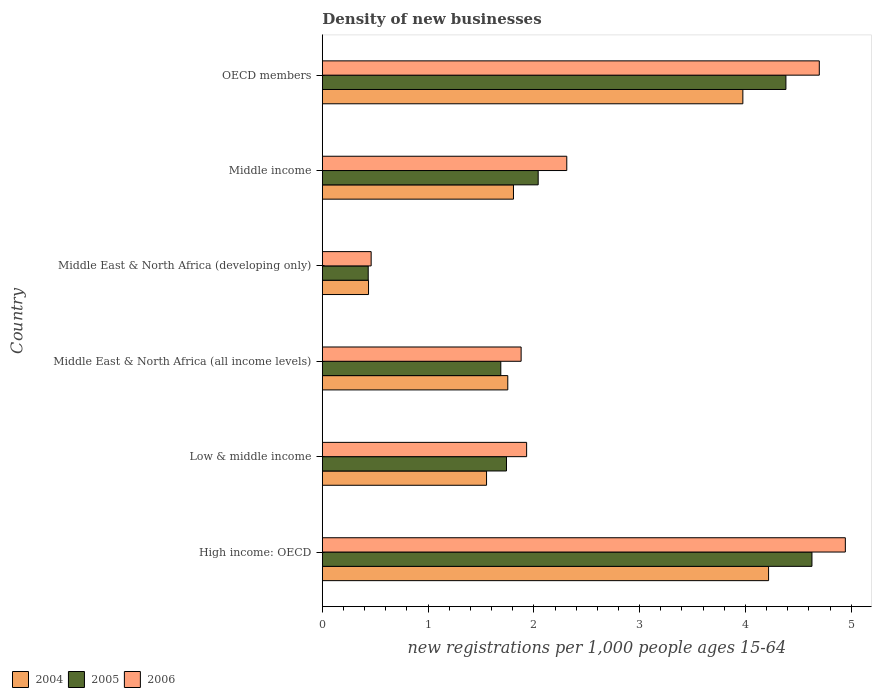How many different coloured bars are there?
Your answer should be very brief. 3. How many groups of bars are there?
Offer a terse response. 6. Are the number of bars per tick equal to the number of legend labels?
Your answer should be compact. Yes. Are the number of bars on each tick of the Y-axis equal?
Give a very brief answer. Yes. What is the number of new registrations in 2004 in Middle income?
Provide a succinct answer. 1.81. Across all countries, what is the maximum number of new registrations in 2004?
Provide a short and direct response. 4.22. Across all countries, what is the minimum number of new registrations in 2005?
Your answer should be compact. 0.43. In which country was the number of new registrations in 2006 maximum?
Your response must be concise. High income: OECD. In which country was the number of new registrations in 2006 minimum?
Ensure brevity in your answer.  Middle East & North Africa (developing only). What is the total number of new registrations in 2006 in the graph?
Offer a terse response. 16.23. What is the difference between the number of new registrations in 2006 in Middle East & North Africa (all income levels) and that in OECD members?
Your answer should be very brief. -2.82. What is the difference between the number of new registrations in 2005 in Middle East & North Africa (developing only) and the number of new registrations in 2004 in Middle East & North Africa (all income levels)?
Make the answer very short. -1.32. What is the average number of new registrations in 2004 per country?
Make the answer very short. 2.29. What is the difference between the number of new registrations in 2005 and number of new registrations in 2006 in OECD members?
Provide a short and direct response. -0.32. In how many countries, is the number of new registrations in 2006 greater than 4.2 ?
Your answer should be compact. 2. What is the ratio of the number of new registrations in 2005 in Middle East & North Africa (developing only) to that in Middle income?
Make the answer very short. 0.21. Is the number of new registrations in 2006 in Middle income less than that in OECD members?
Offer a very short reply. Yes. What is the difference between the highest and the second highest number of new registrations in 2006?
Your response must be concise. 0.25. What is the difference between the highest and the lowest number of new registrations in 2006?
Offer a terse response. 4.48. In how many countries, is the number of new registrations in 2005 greater than the average number of new registrations in 2005 taken over all countries?
Give a very brief answer. 2. What does the 2nd bar from the top in High income: OECD represents?
Provide a succinct answer. 2005. Are all the bars in the graph horizontal?
Provide a short and direct response. Yes. How many countries are there in the graph?
Your answer should be compact. 6. Are the values on the major ticks of X-axis written in scientific E-notation?
Make the answer very short. No. Where does the legend appear in the graph?
Make the answer very short. Bottom left. What is the title of the graph?
Keep it short and to the point. Density of new businesses. Does "1979" appear as one of the legend labels in the graph?
Provide a succinct answer. No. What is the label or title of the X-axis?
Make the answer very short. New registrations per 1,0 people ages 15-64. What is the label or title of the Y-axis?
Make the answer very short. Country. What is the new registrations per 1,000 people ages 15-64 in 2004 in High income: OECD?
Your answer should be very brief. 4.22. What is the new registrations per 1,000 people ages 15-64 in 2005 in High income: OECD?
Your answer should be very brief. 4.63. What is the new registrations per 1,000 people ages 15-64 in 2006 in High income: OECD?
Your answer should be very brief. 4.94. What is the new registrations per 1,000 people ages 15-64 of 2004 in Low & middle income?
Provide a succinct answer. 1.55. What is the new registrations per 1,000 people ages 15-64 of 2005 in Low & middle income?
Offer a very short reply. 1.74. What is the new registrations per 1,000 people ages 15-64 in 2006 in Low & middle income?
Your response must be concise. 1.93. What is the new registrations per 1,000 people ages 15-64 of 2004 in Middle East & North Africa (all income levels)?
Provide a short and direct response. 1.75. What is the new registrations per 1,000 people ages 15-64 in 2005 in Middle East & North Africa (all income levels)?
Provide a short and direct response. 1.69. What is the new registrations per 1,000 people ages 15-64 of 2006 in Middle East & North Africa (all income levels)?
Your answer should be compact. 1.88. What is the new registrations per 1,000 people ages 15-64 of 2004 in Middle East & North Africa (developing only)?
Keep it short and to the point. 0.44. What is the new registrations per 1,000 people ages 15-64 of 2005 in Middle East & North Africa (developing only)?
Offer a very short reply. 0.43. What is the new registrations per 1,000 people ages 15-64 in 2006 in Middle East & North Africa (developing only)?
Provide a short and direct response. 0.46. What is the new registrations per 1,000 people ages 15-64 in 2004 in Middle income?
Provide a succinct answer. 1.81. What is the new registrations per 1,000 people ages 15-64 of 2005 in Middle income?
Provide a short and direct response. 2.04. What is the new registrations per 1,000 people ages 15-64 in 2006 in Middle income?
Provide a succinct answer. 2.31. What is the new registrations per 1,000 people ages 15-64 in 2004 in OECD members?
Your answer should be compact. 3.98. What is the new registrations per 1,000 people ages 15-64 in 2005 in OECD members?
Your answer should be compact. 4.38. What is the new registrations per 1,000 people ages 15-64 of 2006 in OECD members?
Provide a short and direct response. 4.7. Across all countries, what is the maximum new registrations per 1,000 people ages 15-64 in 2004?
Offer a very short reply. 4.22. Across all countries, what is the maximum new registrations per 1,000 people ages 15-64 in 2005?
Offer a terse response. 4.63. Across all countries, what is the maximum new registrations per 1,000 people ages 15-64 of 2006?
Offer a terse response. 4.94. Across all countries, what is the minimum new registrations per 1,000 people ages 15-64 in 2004?
Make the answer very short. 0.44. Across all countries, what is the minimum new registrations per 1,000 people ages 15-64 of 2005?
Provide a short and direct response. 0.43. Across all countries, what is the minimum new registrations per 1,000 people ages 15-64 of 2006?
Keep it short and to the point. 0.46. What is the total new registrations per 1,000 people ages 15-64 in 2004 in the graph?
Offer a terse response. 13.74. What is the total new registrations per 1,000 people ages 15-64 in 2005 in the graph?
Your answer should be very brief. 14.92. What is the total new registrations per 1,000 people ages 15-64 of 2006 in the graph?
Give a very brief answer. 16.23. What is the difference between the new registrations per 1,000 people ages 15-64 of 2004 in High income: OECD and that in Low & middle income?
Ensure brevity in your answer.  2.67. What is the difference between the new registrations per 1,000 people ages 15-64 of 2005 in High income: OECD and that in Low & middle income?
Ensure brevity in your answer.  2.89. What is the difference between the new registrations per 1,000 people ages 15-64 in 2006 in High income: OECD and that in Low & middle income?
Provide a short and direct response. 3.01. What is the difference between the new registrations per 1,000 people ages 15-64 in 2004 in High income: OECD and that in Middle East & North Africa (all income levels)?
Ensure brevity in your answer.  2.47. What is the difference between the new registrations per 1,000 people ages 15-64 in 2005 in High income: OECD and that in Middle East & North Africa (all income levels)?
Offer a terse response. 2.94. What is the difference between the new registrations per 1,000 people ages 15-64 of 2006 in High income: OECD and that in Middle East & North Africa (all income levels)?
Offer a terse response. 3.07. What is the difference between the new registrations per 1,000 people ages 15-64 of 2004 in High income: OECD and that in Middle East & North Africa (developing only)?
Provide a short and direct response. 3.78. What is the difference between the new registrations per 1,000 people ages 15-64 of 2005 in High income: OECD and that in Middle East & North Africa (developing only)?
Ensure brevity in your answer.  4.2. What is the difference between the new registrations per 1,000 people ages 15-64 of 2006 in High income: OECD and that in Middle East & North Africa (developing only)?
Offer a very short reply. 4.48. What is the difference between the new registrations per 1,000 people ages 15-64 of 2004 in High income: OECD and that in Middle income?
Provide a short and direct response. 2.41. What is the difference between the new registrations per 1,000 people ages 15-64 of 2005 in High income: OECD and that in Middle income?
Offer a terse response. 2.59. What is the difference between the new registrations per 1,000 people ages 15-64 in 2006 in High income: OECD and that in Middle income?
Give a very brief answer. 2.63. What is the difference between the new registrations per 1,000 people ages 15-64 of 2004 in High income: OECD and that in OECD members?
Make the answer very short. 0.24. What is the difference between the new registrations per 1,000 people ages 15-64 of 2005 in High income: OECD and that in OECD members?
Make the answer very short. 0.25. What is the difference between the new registrations per 1,000 people ages 15-64 of 2006 in High income: OECD and that in OECD members?
Offer a very short reply. 0.25. What is the difference between the new registrations per 1,000 people ages 15-64 of 2004 in Low & middle income and that in Middle East & North Africa (all income levels)?
Ensure brevity in your answer.  -0.2. What is the difference between the new registrations per 1,000 people ages 15-64 of 2005 in Low & middle income and that in Middle East & North Africa (all income levels)?
Offer a very short reply. 0.05. What is the difference between the new registrations per 1,000 people ages 15-64 in 2006 in Low & middle income and that in Middle East & North Africa (all income levels)?
Your response must be concise. 0.05. What is the difference between the new registrations per 1,000 people ages 15-64 in 2004 in Low & middle income and that in Middle East & North Africa (developing only)?
Provide a succinct answer. 1.12. What is the difference between the new registrations per 1,000 people ages 15-64 in 2005 in Low & middle income and that in Middle East & North Africa (developing only)?
Make the answer very short. 1.31. What is the difference between the new registrations per 1,000 people ages 15-64 of 2006 in Low & middle income and that in Middle East & North Africa (developing only)?
Give a very brief answer. 1.47. What is the difference between the new registrations per 1,000 people ages 15-64 in 2004 in Low & middle income and that in Middle income?
Ensure brevity in your answer.  -0.25. What is the difference between the new registrations per 1,000 people ages 15-64 in 2005 in Low & middle income and that in Middle income?
Offer a terse response. -0.3. What is the difference between the new registrations per 1,000 people ages 15-64 in 2006 in Low & middle income and that in Middle income?
Provide a succinct answer. -0.38. What is the difference between the new registrations per 1,000 people ages 15-64 of 2004 in Low & middle income and that in OECD members?
Offer a terse response. -2.42. What is the difference between the new registrations per 1,000 people ages 15-64 of 2005 in Low & middle income and that in OECD members?
Your answer should be very brief. -2.64. What is the difference between the new registrations per 1,000 people ages 15-64 of 2006 in Low & middle income and that in OECD members?
Give a very brief answer. -2.77. What is the difference between the new registrations per 1,000 people ages 15-64 in 2004 in Middle East & North Africa (all income levels) and that in Middle East & North Africa (developing only)?
Offer a very short reply. 1.32. What is the difference between the new registrations per 1,000 people ages 15-64 of 2005 in Middle East & North Africa (all income levels) and that in Middle East & North Africa (developing only)?
Offer a terse response. 1.25. What is the difference between the new registrations per 1,000 people ages 15-64 in 2006 in Middle East & North Africa (all income levels) and that in Middle East & North Africa (developing only)?
Provide a short and direct response. 1.42. What is the difference between the new registrations per 1,000 people ages 15-64 of 2004 in Middle East & North Africa (all income levels) and that in Middle income?
Keep it short and to the point. -0.05. What is the difference between the new registrations per 1,000 people ages 15-64 of 2005 in Middle East & North Africa (all income levels) and that in Middle income?
Offer a very short reply. -0.35. What is the difference between the new registrations per 1,000 people ages 15-64 in 2006 in Middle East & North Africa (all income levels) and that in Middle income?
Offer a terse response. -0.43. What is the difference between the new registrations per 1,000 people ages 15-64 of 2004 in Middle East & North Africa (all income levels) and that in OECD members?
Your answer should be very brief. -2.22. What is the difference between the new registrations per 1,000 people ages 15-64 in 2005 in Middle East & North Africa (all income levels) and that in OECD members?
Your response must be concise. -2.7. What is the difference between the new registrations per 1,000 people ages 15-64 of 2006 in Middle East & North Africa (all income levels) and that in OECD members?
Offer a very short reply. -2.82. What is the difference between the new registrations per 1,000 people ages 15-64 of 2004 in Middle East & North Africa (developing only) and that in Middle income?
Give a very brief answer. -1.37. What is the difference between the new registrations per 1,000 people ages 15-64 of 2005 in Middle East & North Africa (developing only) and that in Middle income?
Give a very brief answer. -1.61. What is the difference between the new registrations per 1,000 people ages 15-64 in 2006 in Middle East & North Africa (developing only) and that in Middle income?
Give a very brief answer. -1.85. What is the difference between the new registrations per 1,000 people ages 15-64 in 2004 in Middle East & North Africa (developing only) and that in OECD members?
Your answer should be compact. -3.54. What is the difference between the new registrations per 1,000 people ages 15-64 of 2005 in Middle East & North Africa (developing only) and that in OECD members?
Make the answer very short. -3.95. What is the difference between the new registrations per 1,000 people ages 15-64 in 2006 in Middle East & North Africa (developing only) and that in OECD members?
Offer a terse response. -4.24. What is the difference between the new registrations per 1,000 people ages 15-64 in 2004 in Middle income and that in OECD members?
Ensure brevity in your answer.  -2.17. What is the difference between the new registrations per 1,000 people ages 15-64 in 2005 in Middle income and that in OECD members?
Ensure brevity in your answer.  -2.34. What is the difference between the new registrations per 1,000 people ages 15-64 in 2006 in Middle income and that in OECD members?
Keep it short and to the point. -2.39. What is the difference between the new registrations per 1,000 people ages 15-64 in 2004 in High income: OECD and the new registrations per 1,000 people ages 15-64 in 2005 in Low & middle income?
Offer a terse response. 2.48. What is the difference between the new registrations per 1,000 people ages 15-64 in 2004 in High income: OECD and the new registrations per 1,000 people ages 15-64 in 2006 in Low & middle income?
Your response must be concise. 2.29. What is the difference between the new registrations per 1,000 people ages 15-64 of 2005 in High income: OECD and the new registrations per 1,000 people ages 15-64 of 2006 in Low & middle income?
Your answer should be very brief. 2.7. What is the difference between the new registrations per 1,000 people ages 15-64 of 2004 in High income: OECD and the new registrations per 1,000 people ages 15-64 of 2005 in Middle East & North Africa (all income levels)?
Your response must be concise. 2.53. What is the difference between the new registrations per 1,000 people ages 15-64 of 2004 in High income: OECD and the new registrations per 1,000 people ages 15-64 of 2006 in Middle East & North Africa (all income levels)?
Your answer should be compact. 2.34. What is the difference between the new registrations per 1,000 people ages 15-64 of 2005 in High income: OECD and the new registrations per 1,000 people ages 15-64 of 2006 in Middle East & North Africa (all income levels)?
Give a very brief answer. 2.75. What is the difference between the new registrations per 1,000 people ages 15-64 of 2004 in High income: OECD and the new registrations per 1,000 people ages 15-64 of 2005 in Middle East & North Africa (developing only)?
Make the answer very short. 3.79. What is the difference between the new registrations per 1,000 people ages 15-64 in 2004 in High income: OECD and the new registrations per 1,000 people ages 15-64 in 2006 in Middle East & North Africa (developing only)?
Give a very brief answer. 3.76. What is the difference between the new registrations per 1,000 people ages 15-64 in 2005 in High income: OECD and the new registrations per 1,000 people ages 15-64 in 2006 in Middle East & North Africa (developing only)?
Your answer should be very brief. 4.17. What is the difference between the new registrations per 1,000 people ages 15-64 of 2004 in High income: OECD and the new registrations per 1,000 people ages 15-64 of 2005 in Middle income?
Your response must be concise. 2.18. What is the difference between the new registrations per 1,000 people ages 15-64 in 2004 in High income: OECD and the new registrations per 1,000 people ages 15-64 in 2006 in Middle income?
Give a very brief answer. 1.91. What is the difference between the new registrations per 1,000 people ages 15-64 of 2005 in High income: OECD and the new registrations per 1,000 people ages 15-64 of 2006 in Middle income?
Make the answer very short. 2.32. What is the difference between the new registrations per 1,000 people ages 15-64 in 2004 in High income: OECD and the new registrations per 1,000 people ages 15-64 in 2005 in OECD members?
Provide a short and direct response. -0.16. What is the difference between the new registrations per 1,000 people ages 15-64 in 2004 in High income: OECD and the new registrations per 1,000 people ages 15-64 in 2006 in OECD members?
Your answer should be very brief. -0.48. What is the difference between the new registrations per 1,000 people ages 15-64 of 2005 in High income: OECD and the new registrations per 1,000 people ages 15-64 of 2006 in OECD members?
Ensure brevity in your answer.  -0.07. What is the difference between the new registrations per 1,000 people ages 15-64 in 2004 in Low & middle income and the new registrations per 1,000 people ages 15-64 in 2005 in Middle East & North Africa (all income levels)?
Give a very brief answer. -0.13. What is the difference between the new registrations per 1,000 people ages 15-64 in 2004 in Low & middle income and the new registrations per 1,000 people ages 15-64 in 2006 in Middle East & North Africa (all income levels)?
Your response must be concise. -0.33. What is the difference between the new registrations per 1,000 people ages 15-64 in 2005 in Low & middle income and the new registrations per 1,000 people ages 15-64 in 2006 in Middle East & North Africa (all income levels)?
Offer a very short reply. -0.14. What is the difference between the new registrations per 1,000 people ages 15-64 in 2004 in Low & middle income and the new registrations per 1,000 people ages 15-64 in 2005 in Middle East & North Africa (developing only)?
Your response must be concise. 1.12. What is the difference between the new registrations per 1,000 people ages 15-64 in 2004 in Low & middle income and the new registrations per 1,000 people ages 15-64 in 2006 in Middle East & North Africa (developing only)?
Offer a terse response. 1.09. What is the difference between the new registrations per 1,000 people ages 15-64 of 2005 in Low & middle income and the new registrations per 1,000 people ages 15-64 of 2006 in Middle East & North Africa (developing only)?
Give a very brief answer. 1.28. What is the difference between the new registrations per 1,000 people ages 15-64 in 2004 in Low & middle income and the new registrations per 1,000 people ages 15-64 in 2005 in Middle income?
Provide a succinct answer. -0.49. What is the difference between the new registrations per 1,000 people ages 15-64 in 2004 in Low & middle income and the new registrations per 1,000 people ages 15-64 in 2006 in Middle income?
Your response must be concise. -0.76. What is the difference between the new registrations per 1,000 people ages 15-64 in 2005 in Low & middle income and the new registrations per 1,000 people ages 15-64 in 2006 in Middle income?
Make the answer very short. -0.57. What is the difference between the new registrations per 1,000 people ages 15-64 of 2004 in Low & middle income and the new registrations per 1,000 people ages 15-64 of 2005 in OECD members?
Your answer should be compact. -2.83. What is the difference between the new registrations per 1,000 people ages 15-64 in 2004 in Low & middle income and the new registrations per 1,000 people ages 15-64 in 2006 in OECD members?
Your response must be concise. -3.15. What is the difference between the new registrations per 1,000 people ages 15-64 of 2005 in Low & middle income and the new registrations per 1,000 people ages 15-64 of 2006 in OECD members?
Your answer should be compact. -2.96. What is the difference between the new registrations per 1,000 people ages 15-64 of 2004 in Middle East & North Africa (all income levels) and the new registrations per 1,000 people ages 15-64 of 2005 in Middle East & North Africa (developing only)?
Offer a terse response. 1.32. What is the difference between the new registrations per 1,000 people ages 15-64 of 2004 in Middle East & North Africa (all income levels) and the new registrations per 1,000 people ages 15-64 of 2006 in Middle East & North Africa (developing only)?
Provide a succinct answer. 1.29. What is the difference between the new registrations per 1,000 people ages 15-64 in 2005 in Middle East & North Africa (all income levels) and the new registrations per 1,000 people ages 15-64 in 2006 in Middle East & North Africa (developing only)?
Offer a very short reply. 1.23. What is the difference between the new registrations per 1,000 people ages 15-64 of 2004 in Middle East & North Africa (all income levels) and the new registrations per 1,000 people ages 15-64 of 2005 in Middle income?
Your answer should be compact. -0.29. What is the difference between the new registrations per 1,000 people ages 15-64 in 2004 in Middle East & North Africa (all income levels) and the new registrations per 1,000 people ages 15-64 in 2006 in Middle income?
Your answer should be compact. -0.56. What is the difference between the new registrations per 1,000 people ages 15-64 of 2005 in Middle East & North Africa (all income levels) and the new registrations per 1,000 people ages 15-64 of 2006 in Middle income?
Provide a succinct answer. -0.62. What is the difference between the new registrations per 1,000 people ages 15-64 of 2004 in Middle East & North Africa (all income levels) and the new registrations per 1,000 people ages 15-64 of 2005 in OECD members?
Keep it short and to the point. -2.63. What is the difference between the new registrations per 1,000 people ages 15-64 in 2004 in Middle East & North Africa (all income levels) and the new registrations per 1,000 people ages 15-64 in 2006 in OECD members?
Provide a short and direct response. -2.95. What is the difference between the new registrations per 1,000 people ages 15-64 of 2005 in Middle East & North Africa (all income levels) and the new registrations per 1,000 people ages 15-64 of 2006 in OECD members?
Your answer should be very brief. -3.01. What is the difference between the new registrations per 1,000 people ages 15-64 of 2004 in Middle East & North Africa (developing only) and the new registrations per 1,000 people ages 15-64 of 2005 in Middle income?
Make the answer very short. -1.6. What is the difference between the new registrations per 1,000 people ages 15-64 of 2004 in Middle East & North Africa (developing only) and the new registrations per 1,000 people ages 15-64 of 2006 in Middle income?
Your answer should be very brief. -1.87. What is the difference between the new registrations per 1,000 people ages 15-64 of 2005 in Middle East & North Africa (developing only) and the new registrations per 1,000 people ages 15-64 of 2006 in Middle income?
Your answer should be compact. -1.88. What is the difference between the new registrations per 1,000 people ages 15-64 of 2004 in Middle East & North Africa (developing only) and the new registrations per 1,000 people ages 15-64 of 2005 in OECD members?
Make the answer very short. -3.95. What is the difference between the new registrations per 1,000 people ages 15-64 in 2004 in Middle East & North Africa (developing only) and the new registrations per 1,000 people ages 15-64 in 2006 in OECD members?
Make the answer very short. -4.26. What is the difference between the new registrations per 1,000 people ages 15-64 of 2005 in Middle East & North Africa (developing only) and the new registrations per 1,000 people ages 15-64 of 2006 in OECD members?
Your answer should be compact. -4.26. What is the difference between the new registrations per 1,000 people ages 15-64 in 2004 in Middle income and the new registrations per 1,000 people ages 15-64 in 2005 in OECD members?
Make the answer very short. -2.58. What is the difference between the new registrations per 1,000 people ages 15-64 in 2004 in Middle income and the new registrations per 1,000 people ages 15-64 in 2006 in OECD members?
Provide a short and direct response. -2.89. What is the difference between the new registrations per 1,000 people ages 15-64 of 2005 in Middle income and the new registrations per 1,000 people ages 15-64 of 2006 in OECD members?
Offer a very short reply. -2.66. What is the average new registrations per 1,000 people ages 15-64 in 2004 per country?
Provide a short and direct response. 2.29. What is the average new registrations per 1,000 people ages 15-64 in 2005 per country?
Your response must be concise. 2.49. What is the average new registrations per 1,000 people ages 15-64 in 2006 per country?
Your answer should be compact. 2.7. What is the difference between the new registrations per 1,000 people ages 15-64 in 2004 and new registrations per 1,000 people ages 15-64 in 2005 in High income: OECD?
Provide a short and direct response. -0.41. What is the difference between the new registrations per 1,000 people ages 15-64 of 2004 and new registrations per 1,000 people ages 15-64 of 2006 in High income: OECD?
Offer a very short reply. -0.73. What is the difference between the new registrations per 1,000 people ages 15-64 of 2005 and new registrations per 1,000 people ages 15-64 of 2006 in High income: OECD?
Your answer should be compact. -0.32. What is the difference between the new registrations per 1,000 people ages 15-64 of 2004 and new registrations per 1,000 people ages 15-64 of 2005 in Low & middle income?
Provide a succinct answer. -0.19. What is the difference between the new registrations per 1,000 people ages 15-64 of 2004 and new registrations per 1,000 people ages 15-64 of 2006 in Low & middle income?
Offer a terse response. -0.38. What is the difference between the new registrations per 1,000 people ages 15-64 in 2005 and new registrations per 1,000 people ages 15-64 in 2006 in Low & middle income?
Give a very brief answer. -0.19. What is the difference between the new registrations per 1,000 people ages 15-64 of 2004 and new registrations per 1,000 people ages 15-64 of 2005 in Middle East & North Africa (all income levels)?
Your answer should be compact. 0.07. What is the difference between the new registrations per 1,000 people ages 15-64 of 2004 and new registrations per 1,000 people ages 15-64 of 2006 in Middle East & North Africa (all income levels)?
Offer a terse response. -0.13. What is the difference between the new registrations per 1,000 people ages 15-64 of 2005 and new registrations per 1,000 people ages 15-64 of 2006 in Middle East & North Africa (all income levels)?
Offer a very short reply. -0.19. What is the difference between the new registrations per 1,000 people ages 15-64 of 2004 and new registrations per 1,000 people ages 15-64 of 2005 in Middle East & North Africa (developing only)?
Your answer should be very brief. 0. What is the difference between the new registrations per 1,000 people ages 15-64 of 2004 and new registrations per 1,000 people ages 15-64 of 2006 in Middle East & North Africa (developing only)?
Make the answer very short. -0.02. What is the difference between the new registrations per 1,000 people ages 15-64 in 2005 and new registrations per 1,000 people ages 15-64 in 2006 in Middle East & North Africa (developing only)?
Provide a short and direct response. -0.03. What is the difference between the new registrations per 1,000 people ages 15-64 in 2004 and new registrations per 1,000 people ages 15-64 in 2005 in Middle income?
Keep it short and to the point. -0.23. What is the difference between the new registrations per 1,000 people ages 15-64 in 2004 and new registrations per 1,000 people ages 15-64 in 2006 in Middle income?
Your answer should be compact. -0.5. What is the difference between the new registrations per 1,000 people ages 15-64 in 2005 and new registrations per 1,000 people ages 15-64 in 2006 in Middle income?
Make the answer very short. -0.27. What is the difference between the new registrations per 1,000 people ages 15-64 in 2004 and new registrations per 1,000 people ages 15-64 in 2005 in OECD members?
Your response must be concise. -0.41. What is the difference between the new registrations per 1,000 people ages 15-64 of 2004 and new registrations per 1,000 people ages 15-64 of 2006 in OECD members?
Provide a succinct answer. -0.72. What is the difference between the new registrations per 1,000 people ages 15-64 in 2005 and new registrations per 1,000 people ages 15-64 in 2006 in OECD members?
Ensure brevity in your answer.  -0.32. What is the ratio of the new registrations per 1,000 people ages 15-64 in 2004 in High income: OECD to that in Low & middle income?
Ensure brevity in your answer.  2.72. What is the ratio of the new registrations per 1,000 people ages 15-64 in 2005 in High income: OECD to that in Low & middle income?
Keep it short and to the point. 2.66. What is the ratio of the new registrations per 1,000 people ages 15-64 of 2006 in High income: OECD to that in Low & middle income?
Your response must be concise. 2.56. What is the ratio of the new registrations per 1,000 people ages 15-64 of 2004 in High income: OECD to that in Middle East & North Africa (all income levels)?
Your response must be concise. 2.41. What is the ratio of the new registrations per 1,000 people ages 15-64 in 2005 in High income: OECD to that in Middle East & North Africa (all income levels)?
Your answer should be very brief. 2.74. What is the ratio of the new registrations per 1,000 people ages 15-64 of 2006 in High income: OECD to that in Middle East & North Africa (all income levels)?
Your response must be concise. 2.63. What is the ratio of the new registrations per 1,000 people ages 15-64 of 2004 in High income: OECD to that in Middle East & North Africa (developing only)?
Make the answer very short. 9.66. What is the ratio of the new registrations per 1,000 people ages 15-64 in 2005 in High income: OECD to that in Middle East & North Africa (developing only)?
Your answer should be very brief. 10.67. What is the ratio of the new registrations per 1,000 people ages 15-64 in 2006 in High income: OECD to that in Middle East & North Africa (developing only)?
Your response must be concise. 10.71. What is the ratio of the new registrations per 1,000 people ages 15-64 in 2004 in High income: OECD to that in Middle income?
Offer a very short reply. 2.33. What is the ratio of the new registrations per 1,000 people ages 15-64 in 2005 in High income: OECD to that in Middle income?
Provide a short and direct response. 2.27. What is the ratio of the new registrations per 1,000 people ages 15-64 of 2006 in High income: OECD to that in Middle income?
Your response must be concise. 2.14. What is the ratio of the new registrations per 1,000 people ages 15-64 of 2004 in High income: OECD to that in OECD members?
Offer a terse response. 1.06. What is the ratio of the new registrations per 1,000 people ages 15-64 of 2005 in High income: OECD to that in OECD members?
Your answer should be very brief. 1.06. What is the ratio of the new registrations per 1,000 people ages 15-64 of 2006 in High income: OECD to that in OECD members?
Your answer should be compact. 1.05. What is the ratio of the new registrations per 1,000 people ages 15-64 in 2004 in Low & middle income to that in Middle East & North Africa (all income levels)?
Offer a very short reply. 0.89. What is the ratio of the new registrations per 1,000 people ages 15-64 of 2005 in Low & middle income to that in Middle East & North Africa (all income levels)?
Provide a succinct answer. 1.03. What is the ratio of the new registrations per 1,000 people ages 15-64 of 2006 in Low & middle income to that in Middle East & North Africa (all income levels)?
Make the answer very short. 1.03. What is the ratio of the new registrations per 1,000 people ages 15-64 of 2004 in Low & middle income to that in Middle East & North Africa (developing only)?
Keep it short and to the point. 3.55. What is the ratio of the new registrations per 1,000 people ages 15-64 in 2005 in Low & middle income to that in Middle East & North Africa (developing only)?
Your answer should be compact. 4.01. What is the ratio of the new registrations per 1,000 people ages 15-64 of 2006 in Low & middle income to that in Middle East & North Africa (developing only)?
Offer a terse response. 4.18. What is the ratio of the new registrations per 1,000 people ages 15-64 in 2004 in Low & middle income to that in Middle income?
Your answer should be compact. 0.86. What is the ratio of the new registrations per 1,000 people ages 15-64 in 2005 in Low & middle income to that in Middle income?
Make the answer very short. 0.85. What is the ratio of the new registrations per 1,000 people ages 15-64 in 2006 in Low & middle income to that in Middle income?
Your answer should be compact. 0.84. What is the ratio of the new registrations per 1,000 people ages 15-64 in 2004 in Low & middle income to that in OECD members?
Provide a succinct answer. 0.39. What is the ratio of the new registrations per 1,000 people ages 15-64 in 2005 in Low & middle income to that in OECD members?
Keep it short and to the point. 0.4. What is the ratio of the new registrations per 1,000 people ages 15-64 of 2006 in Low & middle income to that in OECD members?
Your response must be concise. 0.41. What is the ratio of the new registrations per 1,000 people ages 15-64 in 2004 in Middle East & North Africa (all income levels) to that in Middle East & North Africa (developing only)?
Ensure brevity in your answer.  4.01. What is the ratio of the new registrations per 1,000 people ages 15-64 of 2005 in Middle East & North Africa (all income levels) to that in Middle East & North Africa (developing only)?
Keep it short and to the point. 3.89. What is the ratio of the new registrations per 1,000 people ages 15-64 of 2006 in Middle East & North Africa (all income levels) to that in Middle East & North Africa (developing only)?
Offer a very short reply. 4.07. What is the ratio of the new registrations per 1,000 people ages 15-64 of 2004 in Middle East & North Africa (all income levels) to that in Middle income?
Make the answer very short. 0.97. What is the ratio of the new registrations per 1,000 people ages 15-64 of 2005 in Middle East & North Africa (all income levels) to that in Middle income?
Provide a succinct answer. 0.83. What is the ratio of the new registrations per 1,000 people ages 15-64 in 2006 in Middle East & North Africa (all income levels) to that in Middle income?
Offer a terse response. 0.81. What is the ratio of the new registrations per 1,000 people ages 15-64 in 2004 in Middle East & North Africa (all income levels) to that in OECD members?
Your response must be concise. 0.44. What is the ratio of the new registrations per 1,000 people ages 15-64 in 2005 in Middle East & North Africa (all income levels) to that in OECD members?
Make the answer very short. 0.39. What is the ratio of the new registrations per 1,000 people ages 15-64 of 2004 in Middle East & North Africa (developing only) to that in Middle income?
Provide a short and direct response. 0.24. What is the ratio of the new registrations per 1,000 people ages 15-64 of 2005 in Middle East & North Africa (developing only) to that in Middle income?
Give a very brief answer. 0.21. What is the ratio of the new registrations per 1,000 people ages 15-64 in 2006 in Middle East & North Africa (developing only) to that in Middle income?
Ensure brevity in your answer.  0.2. What is the ratio of the new registrations per 1,000 people ages 15-64 in 2004 in Middle East & North Africa (developing only) to that in OECD members?
Your response must be concise. 0.11. What is the ratio of the new registrations per 1,000 people ages 15-64 of 2005 in Middle East & North Africa (developing only) to that in OECD members?
Provide a succinct answer. 0.1. What is the ratio of the new registrations per 1,000 people ages 15-64 in 2006 in Middle East & North Africa (developing only) to that in OECD members?
Provide a short and direct response. 0.1. What is the ratio of the new registrations per 1,000 people ages 15-64 of 2004 in Middle income to that in OECD members?
Keep it short and to the point. 0.45. What is the ratio of the new registrations per 1,000 people ages 15-64 of 2005 in Middle income to that in OECD members?
Provide a succinct answer. 0.47. What is the ratio of the new registrations per 1,000 people ages 15-64 in 2006 in Middle income to that in OECD members?
Offer a terse response. 0.49. What is the difference between the highest and the second highest new registrations per 1,000 people ages 15-64 in 2004?
Ensure brevity in your answer.  0.24. What is the difference between the highest and the second highest new registrations per 1,000 people ages 15-64 of 2005?
Offer a very short reply. 0.25. What is the difference between the highest and the second highest new registrations per 1,000 people ages 15-64 of 2006?
Your response must be concise. 0.25. What is the difference between the highest and the lowest new registrations per 1,000 people ages 15-64 in 2004?
Your answer should be very brief. 3.78. What is the difference between the highest and the lowest new registrations per 1,000 people ages 15-64 of 2005?
Your response must be concise. 4.2. What is the difference between the highest and the lowest new registrations per 1,000 people ages 15-64 of 2006?
Your response must be concise. 4.48. 